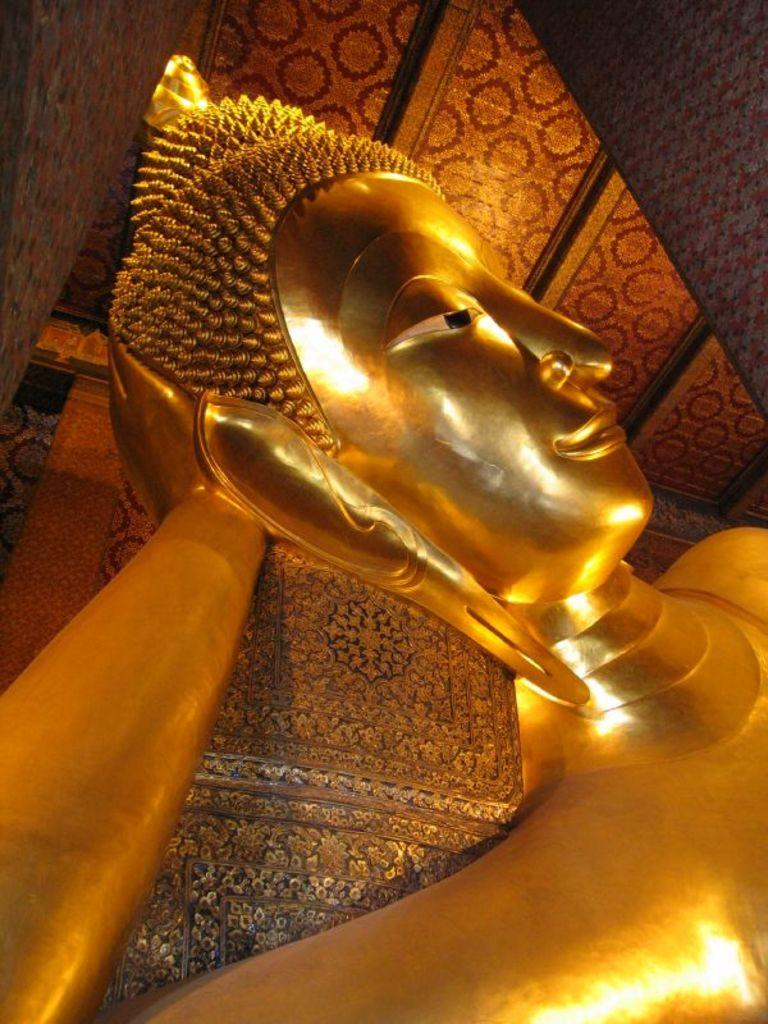What is the main subject in the image? There is a statue in the image. What other architectural element can be seen in the image? There is a pillar in the image. What decorative feature is present on the roof in the image? There is a floral design on the roof in the image. What type of yam is being used to improve the acoustics in the image? There is no yam present in the image, and the image does not depict any acoustic improvements. 